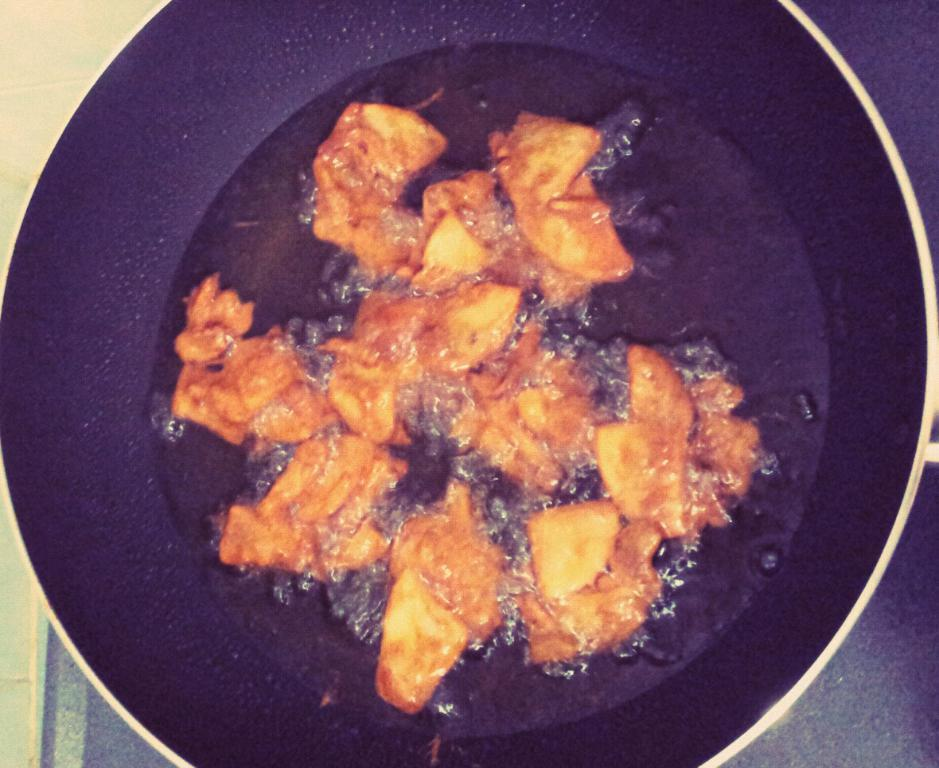What color is the bowl in the image? The bowl in the image is black. What is inside the bowl? There is oil and food inside the bowl. What is the color of the food in the bowl? The food in the bowl is brown in color. Can you see any creatures with fangs in the image? There are no creatures or fangs present in the image; it features a black bowl with oil and brown food. 